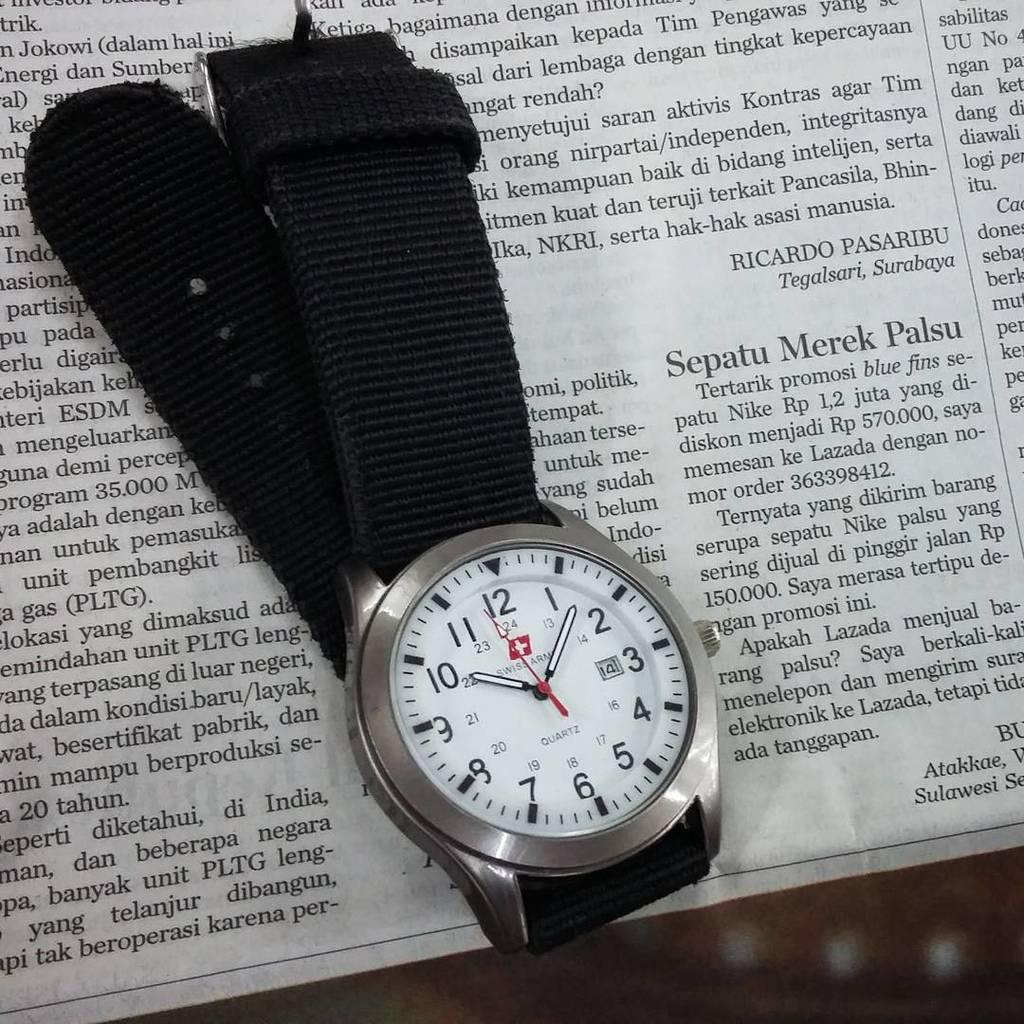What number is the second hand closest to?
Give a very brief answer. 12. Is this watch made by swiss army?
Make the answer very short. Yes. 